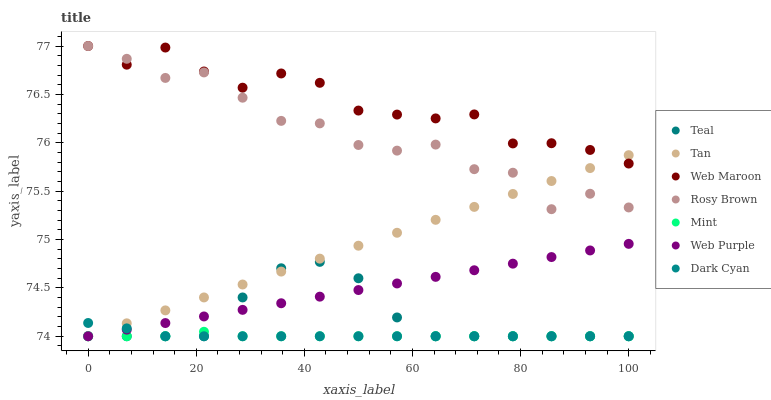Does Mint have the minimum area under the curve?
Answer yes or no. Yes. Does Web Maroon have the maximum area under the curve?
Answer yes or no. Yes. Does Web Purple have the minimum area under the curve?
Answer yes or no. No. Does Web Purple have the maximum area under the curve?
Answer yes or no. No. Is Tan the smoothest?
Answer yes or no. Yes. Is Rosy Brown the roughest?
Answer yes or no. Yes. Is Web Maroon the smoothest?
Answer yes or no. No. Is Web Maroon the roughest?
Answer yes or no. No. Does Web Purple have the lowest value?
Answer yes or no. Yes. Does Web Maroon have the lowest value?
Answer yes or no. No. Does Web Maroon have the highest value?
Answer yes or no. Yes. Does Web Purple have the highest value?
Answer yes or no. No. Is Mint less than Web Maroon?
Answer yes or no. Yes. Is Web Maroon greater than Web Purple?
Answer yes or no. Yes. Does Dark Cyan intersect Web Purple?
Answer yes or no. Yes. Is Dark Cyan less than Web Purple?
Answer yes or no. No. Is Dark Cyan greater than Web Purple?
Answer yes or no. No. Does Mint intersect Web Maroon?
Answer yes or no. No. 